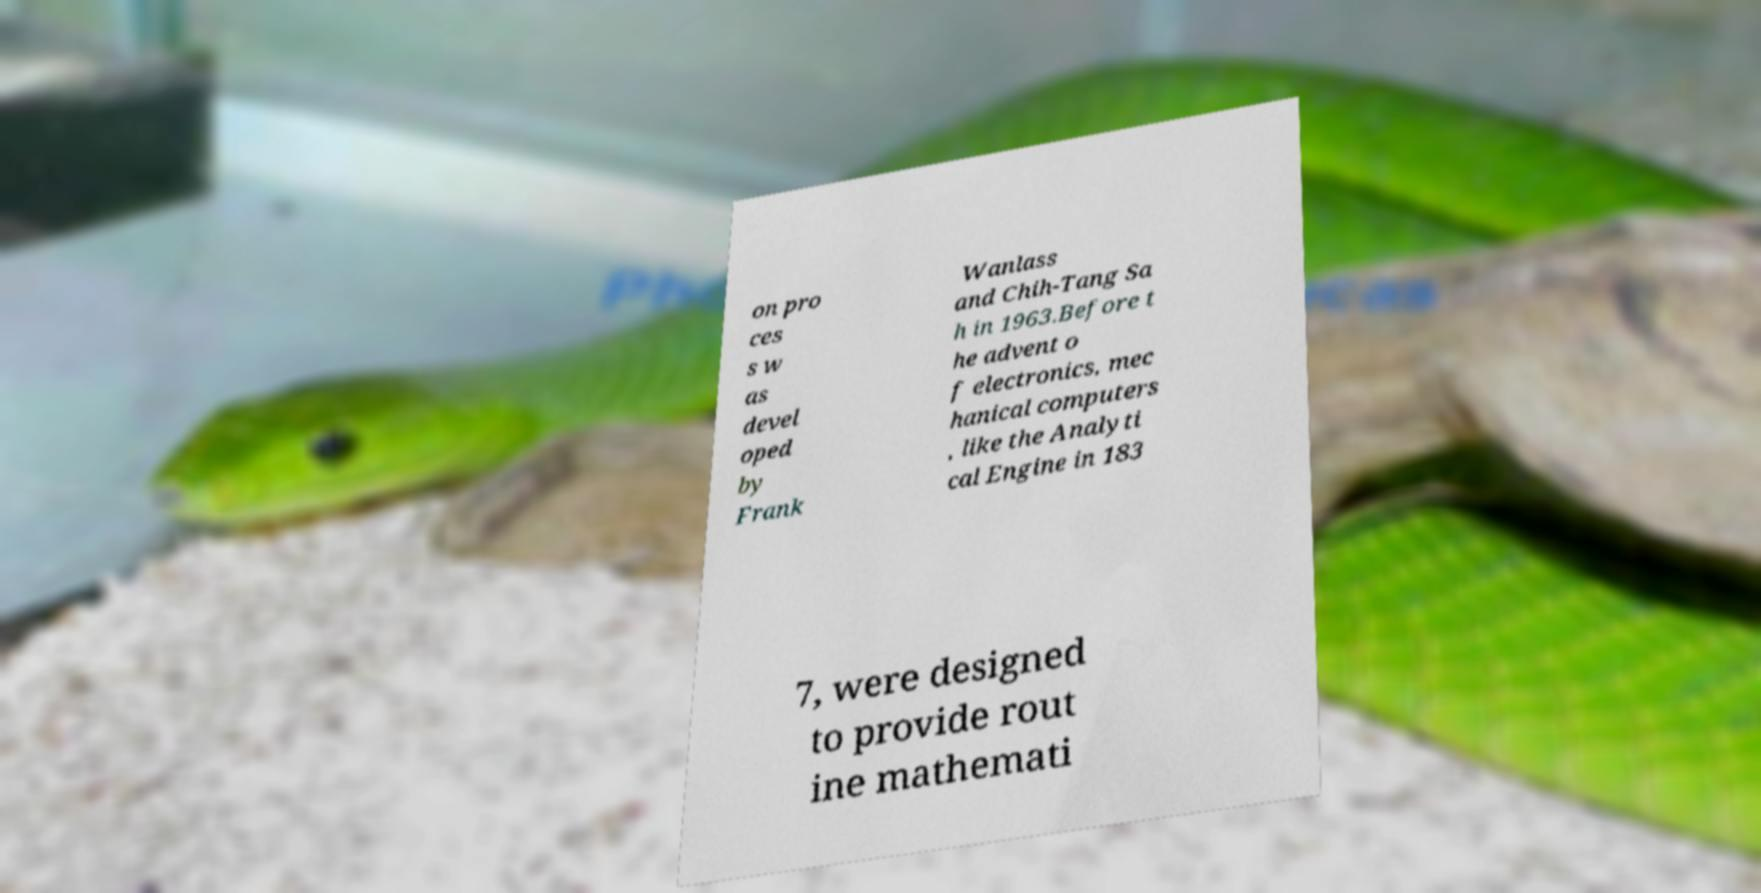Could you extract and type out the text from this image? on pro ces s w as devel oped by Frank Wanlass and Chih-Tang Sa h in 1963.Before t he advent o f electronics, mec hanical computers , like the Analyti cal Engine in 183 7, were designed to provide rout ine mathemati 